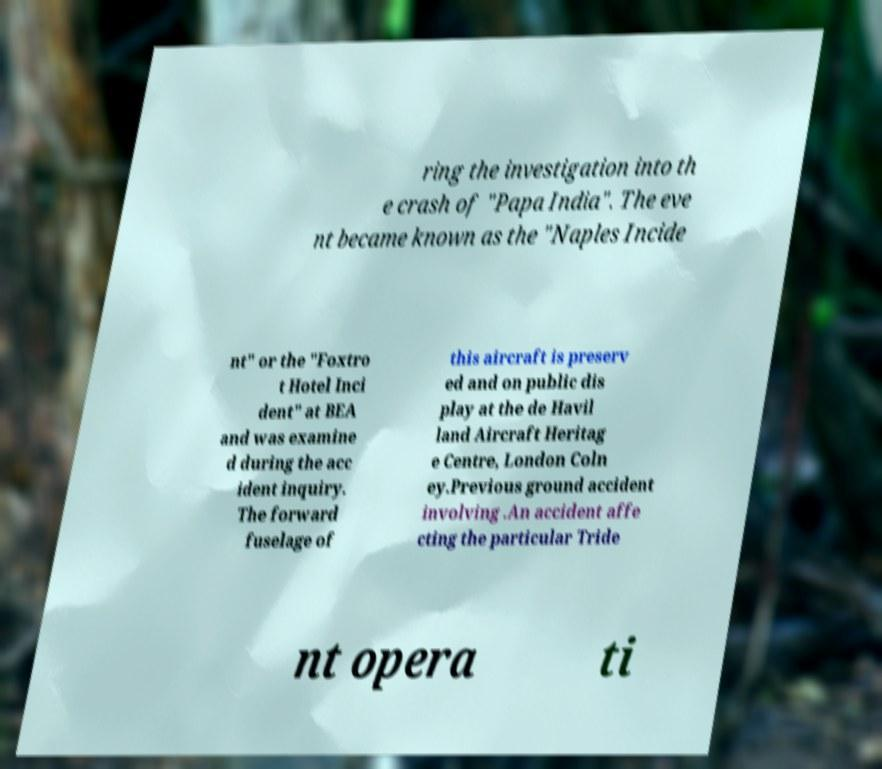There's text embedded in this image that I need extracted. Can you transcribe it verbatim? ring the investigation into th e crash of "Papa India". The eve nt became known as the "Naples Incide nt" or the "Foxtro t Hotel Inci dent" at BEA and was examine d during the acc ident inquiry. The forward fuselage of this aircraft is preserv ed and on public dis play at the de Havil land Aircraft Heritag e Centre, London Coln ey.Previous ground accident involving .An accident affe cting the particular Tride nt opera ti 